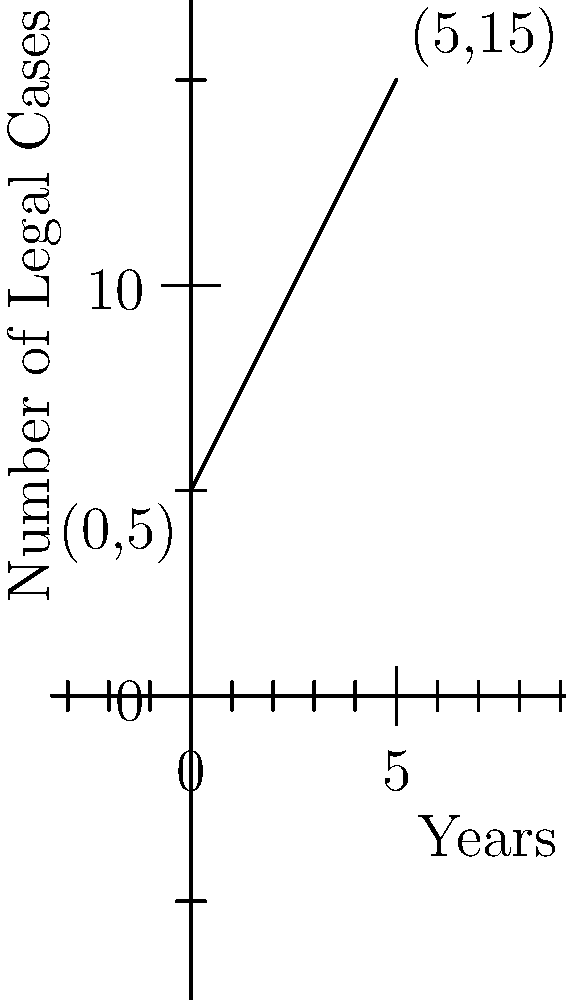In your analysis of legal trends, you've plotted the number of high-profile cases over a 5-year period. The graph shows a linear trend starting at 5 cases in year 0 and reaching 15 cases by year 5. What is the slope of this trend line, representing the average annual increase in high-profile cases? To find the slope of the line, we can use the slope formula:

$$ \text{slope} = \frac{y_2 - y_1}{x_2 - x_1} $$

Where $(x_1, y_1)$ is the starting point and $(x_2, y_2)$ is the ending point.

From the graph, we can identify:
$(x_1, y_1) = (0, 5)$ (starting point)
$(x_2, y_2) = (5, 15)$ (ending point)

Plugging these into the slope formula:

$$ \text{slope} = \frac{15 - 5}{5 - 0} = \frac{10}{5} = 2 $$

This slope of 2 indicates that, on average, there are 2 additional high-profile cases each year over the 5-year period.
Answer: 2 cases per year 